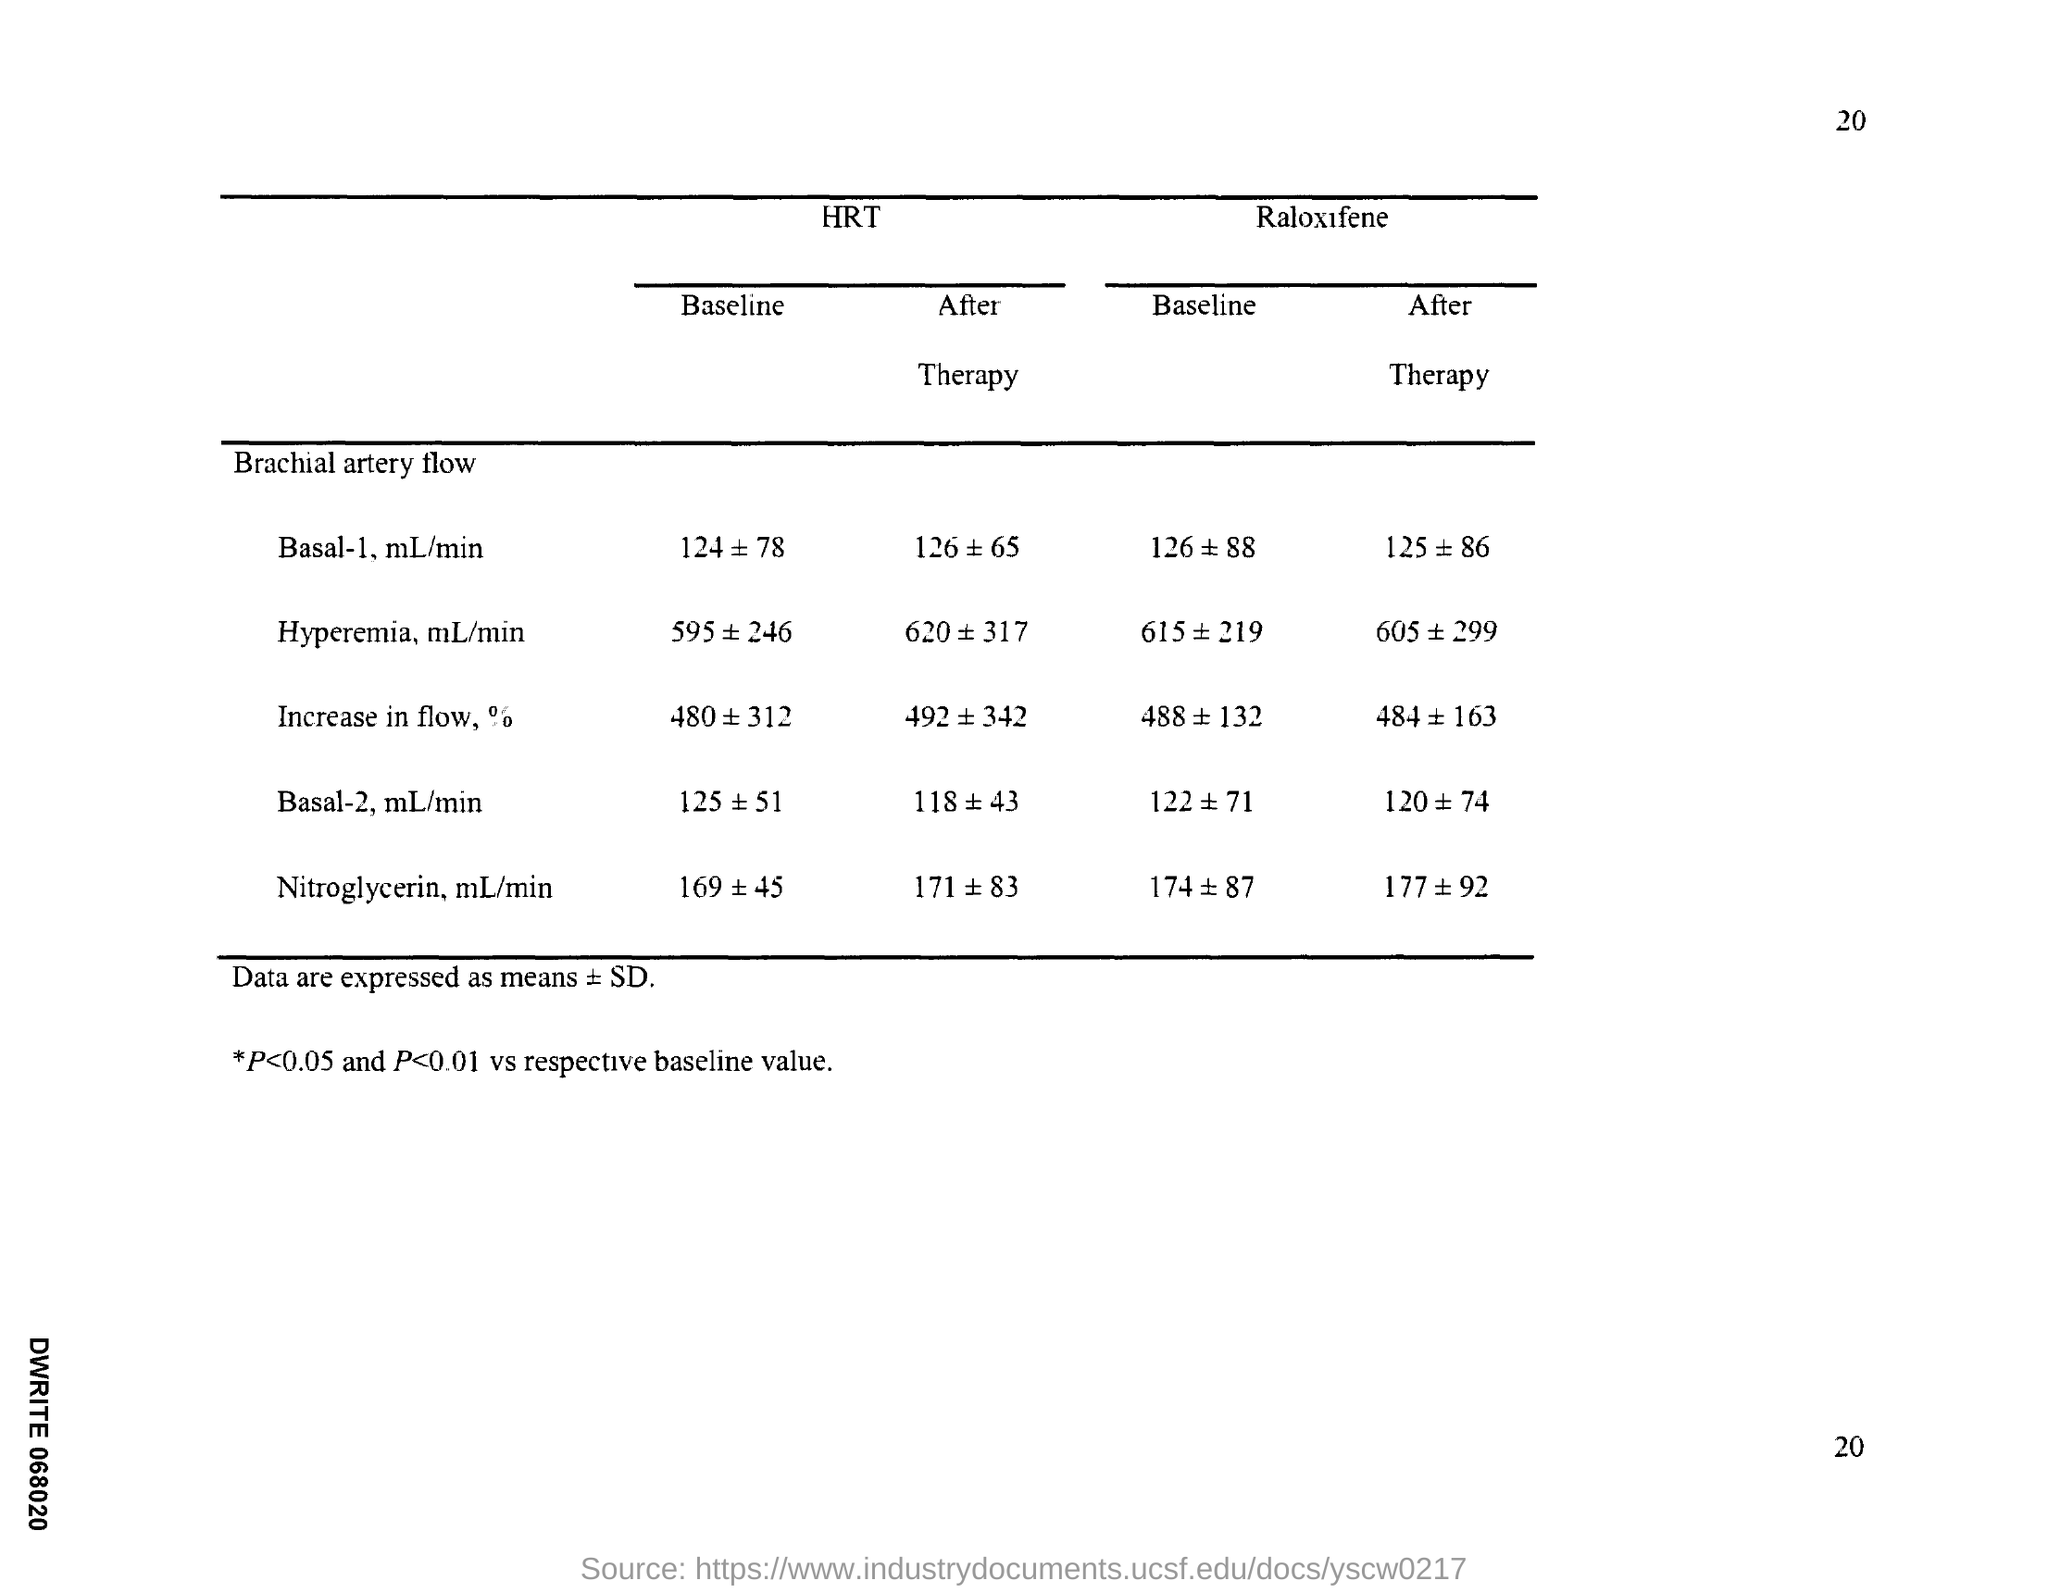What is the page number?
Keep it short and to the point. 20. 